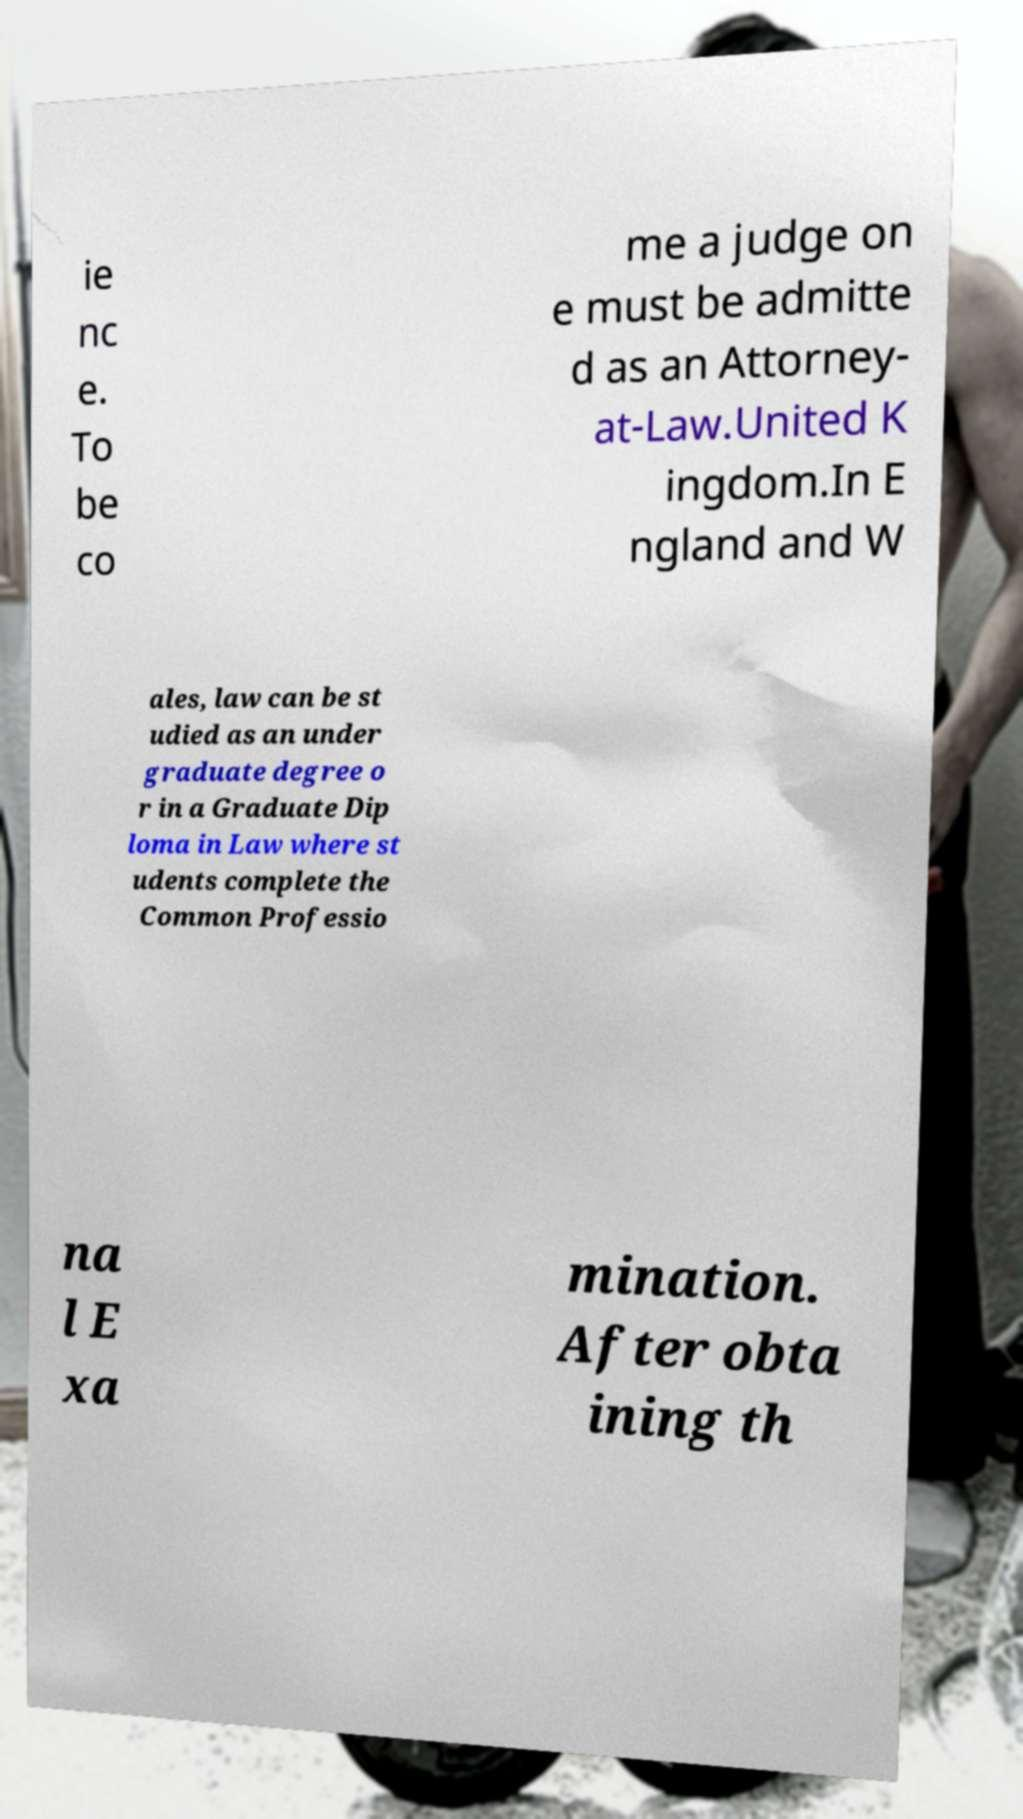Can you read and provide the text displayed in the image?This photo seems to have some interesting text. Can you extract and type it out for me? ie nc e. To be co me a judge on e must be admitte d as an Attorney- at-Law.United K ingdom.In E ngland and W ales, law can be st udied as an under graduate degree o r in a Graduate Dip loma in Law where st udents complete the Common Professio na l E xa mination. After obta ining th 